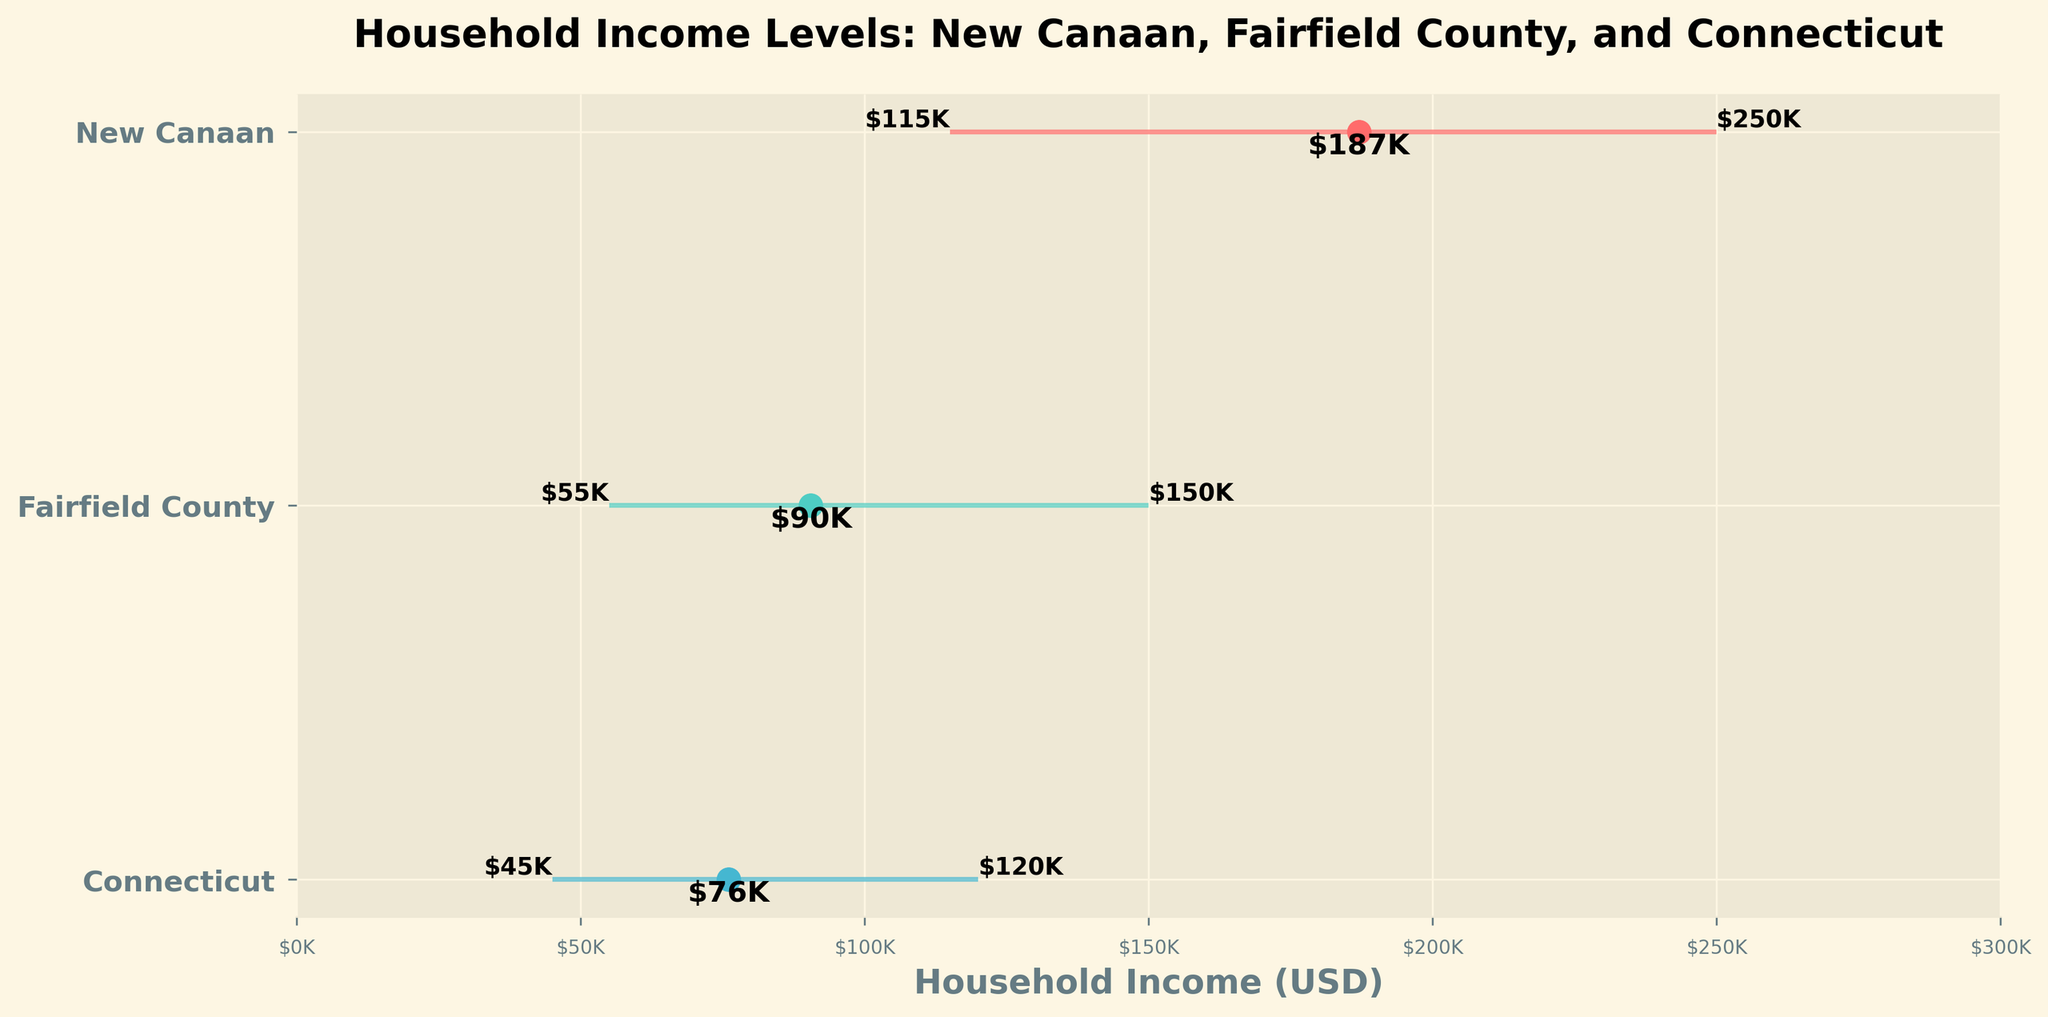What is the median household income in New Canaan? The median household income is represented by the dot on the plot for New Canaan. The value next to the dot is $187K.
Answer: $187K What is the title of the plot? The title of the plot is displayed at the top of the figure. It reads "Household Income Levels: New Canaan, Fairfield County, and Connecticut".
Answer: Household Income Levels: New Canaan, Fairfield County, and Connecticut Which region has the highest 75th percentile household income? The highest 75th percentile household income is represented by the right-end of the range line for the respective region. New Canaan has the highest value at $250K.
Answer: New Canaan How does the 25th percentile household income in Fairfield County compare to that in Connecticut? The 25th percentile household incomes are displayed on the plot. For Fairfield County, it's $55K, and for Connecticut, it’s $45K. Fairfield County's 25th percentile is higher.
Answer: Fairfield County’s is higher What is the range of household incomes in New Canaan? The range of household incomes is determined by the difference between the 75th and 25th percentiles. For New Canaan, it's $250K - $115K = $135K.
Answer: $135K How much higher is the median household income in New Canaan compared to Connecticut? The median household incomes are shown on the plot. For New Canaan, it's $187K, and for Connecticut, it's $76K. The difference is $187K - $76K = $111K.
Answer: $111K What regions are compared in this plot? The regions compared are listed on the y-axis. They are New Canaan, Fairfield County, and Connecticut.
Answer: New Canaan, Fairfield County, and Connecticut Which region has the lowest 25th percentile household income? The lowest 25th percentile household income is the leftmost point of the range line for that region. Connecticut has the lowest value at $45K.
Answer: Connecticut What is the income range within Fairfield County? The income range is calculated by subtracting the 25th percentile from the 75th percentile. For Fairfield County, it's $150K - $55K = $95K.
Answer: $95K 